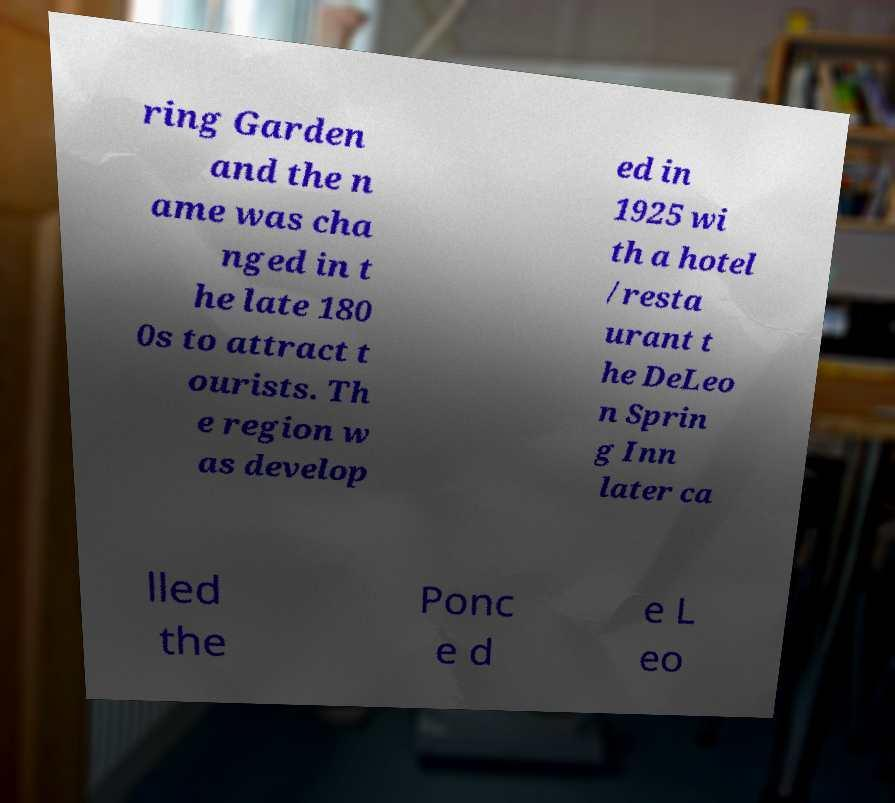Can you read and provide the text displayed in the image?This photo seems to have some interesting text. Can you extract and type it out for me? ring Garden and the n ame was cha nged in t he late 180 0s to attract t ourists. Th e region w as develop ed in 1925 wi th a hotel /resta urant t he DeLeo n Sprin g Inn later ca lled the Ponc e d e L eo 